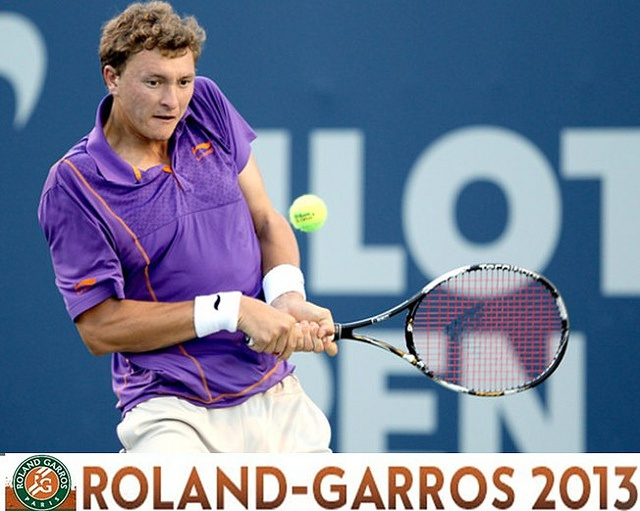Describe the objects in this image and their specific colors. I can see people in blue, white, purple, and navy tones, tennis racket in blue, purple, lightgray, and darkgray tones, and sports ball in blue, khaki, lightyellow, and lightgreen tones in this image. 